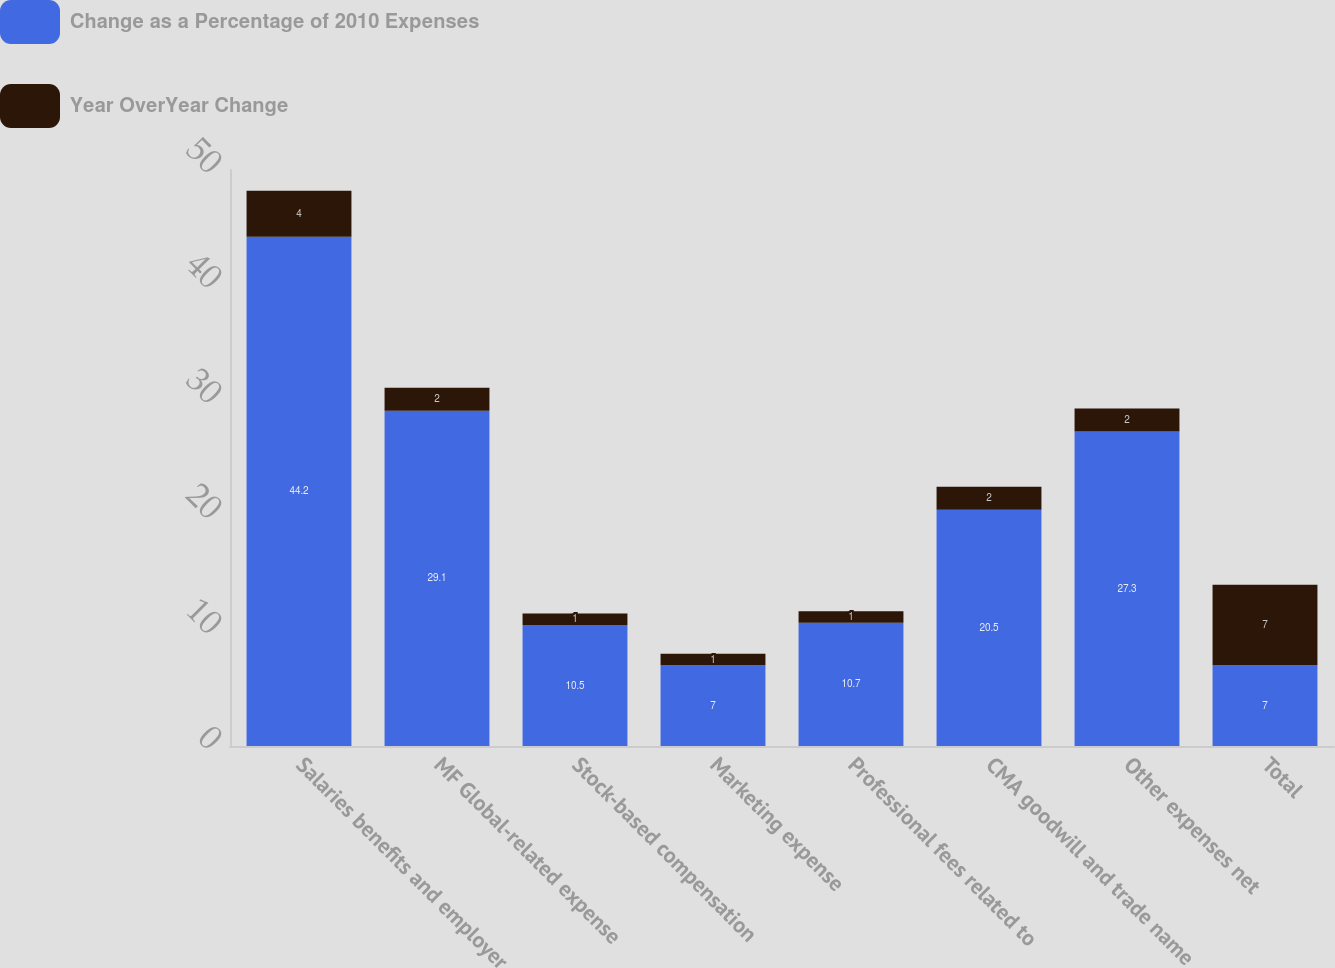<chart> <loc_0><loc_0><loc_500><loc_500><stacked_bar_chart><ecel><fcel>Salaries benefits and employer<fcel>MF Global-related expense<fcel>Stock-based compensation<fcel>Marketing expense<fcel>Professional fees related to<fcel>CMA goodwill and trade name<fcel>Other expenses net<fcel>Total<nl><fcel>Change as a Percentage of 2010 Expenses<fcel>44.2<fcel>29.1<fcel>10.5<fcel>7<fcel>10.7<fcel>20.5<fcel>27.3<fcel>7<nl><fcel>Year OverYear Change<fcel>4<fcel>2<fcel>1<fcel>1<fcel>1<fcel>2<fcel>2<fcel>7<nl></chart> 